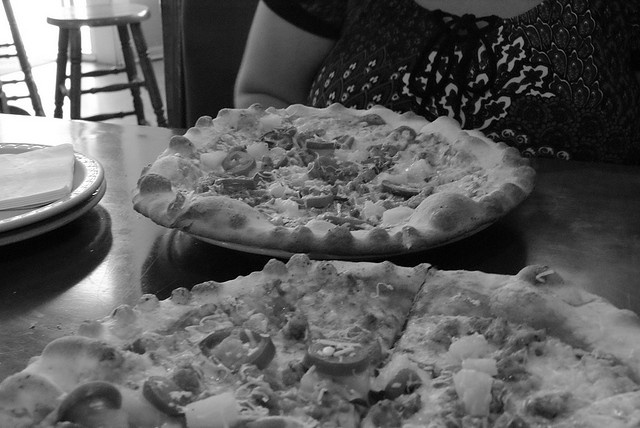Describe the objects in this image and their specific colors. I can see pizza in white, gray, black, and lightgray tones, people in black, gray, and white tones, pizza in white, gray, black, and lightgray tones, dining table in white, black, gray, and darkgray tones, and chair in white, black, darkgray, and gray tones in this image. 